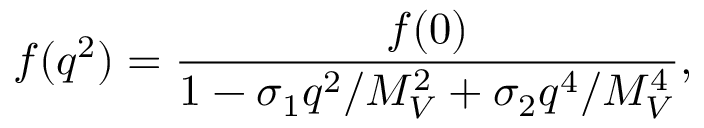Convert formula to latex. <formula><loc_0><loc_0><loc_500><loc_500>f ( q ^ { 2 } ) = \frac { f ( 0 ) } { 1 - \sigma _ { 1 } q ^ { 2 } / M _ { V } ^ { 2 } + \sigma _ { 2 } q ^ { 4 } / M _ { V } ^ { 4 } } ,</formula> 